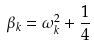<formula> <loc_0><loc_0><loc_500><loc_500>\beta _ { k } = \omega _ { k } ^ { 2 } + \frac { 1 } { 4 }</formula> 